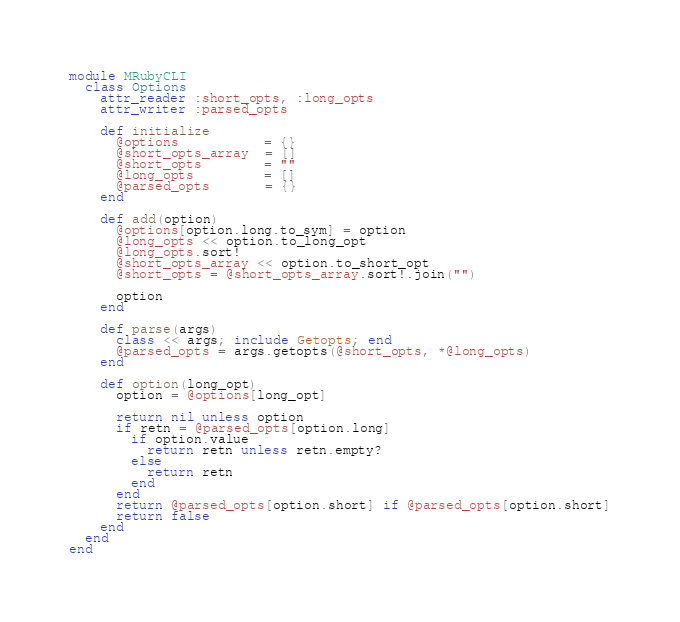<code> <loc_0><loc_0><loc_500><loc_500><_Ruby_>module MRubyCLI
  class Options
    attr_reader :short_opts, :long_opts
    attr_writer :parsed_opts

    def initialize
      @options           = {}
      @short_opts_array  = []
      @short_opts        = ""
      @long_opts         = []
      @parsed_opts       = {}
    end

    def add(option)
      @options[option.long.to_sym] = option
      @long_opts << option.to_long_opt
      @long_opts.sort!
      @short_opts_array << option.to_short_opt
      @short_opts = @short_opts_array.sort!.join("")

      option
    end

    def parse(args)
      class << args; include Getopts; end
      @parsed_opts = args.getopts(@short_opts, *@long_opts)
    end

    def option(long_opt)
      option = @options[long_opt]

      return nil unless option
      if retn = @parsed_opts[option.long]
        if option.value
          return retn unless retn.empty?
        else
          return retn
        end
      end
      return @parsed_opts[option.short] if @parsed_opts[option.short]
      return false
    end
  end
end
</code> 